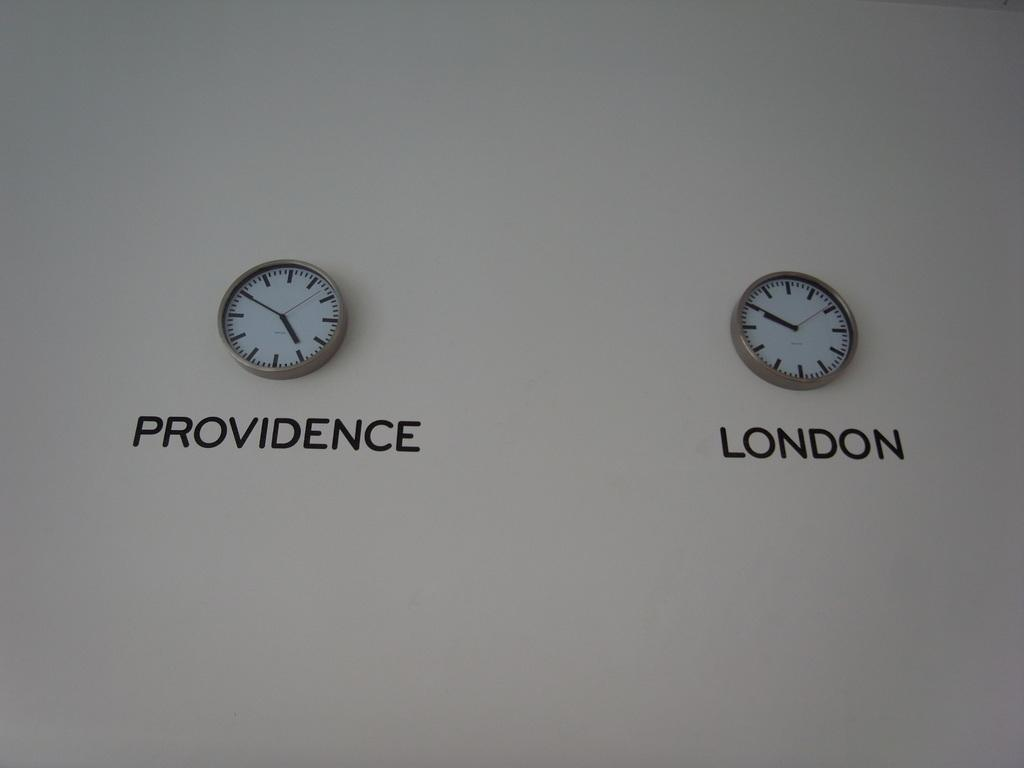How many clocks are on the wall in the image? There are two clocks on the wall in the image. What time zones are represented by the clocks? One clock shows Providence time, and the other clock shows London time. What type of branch is the aunt holding in the image? There is no aunt or branch present in the image; it only features two clocks on the wall. 